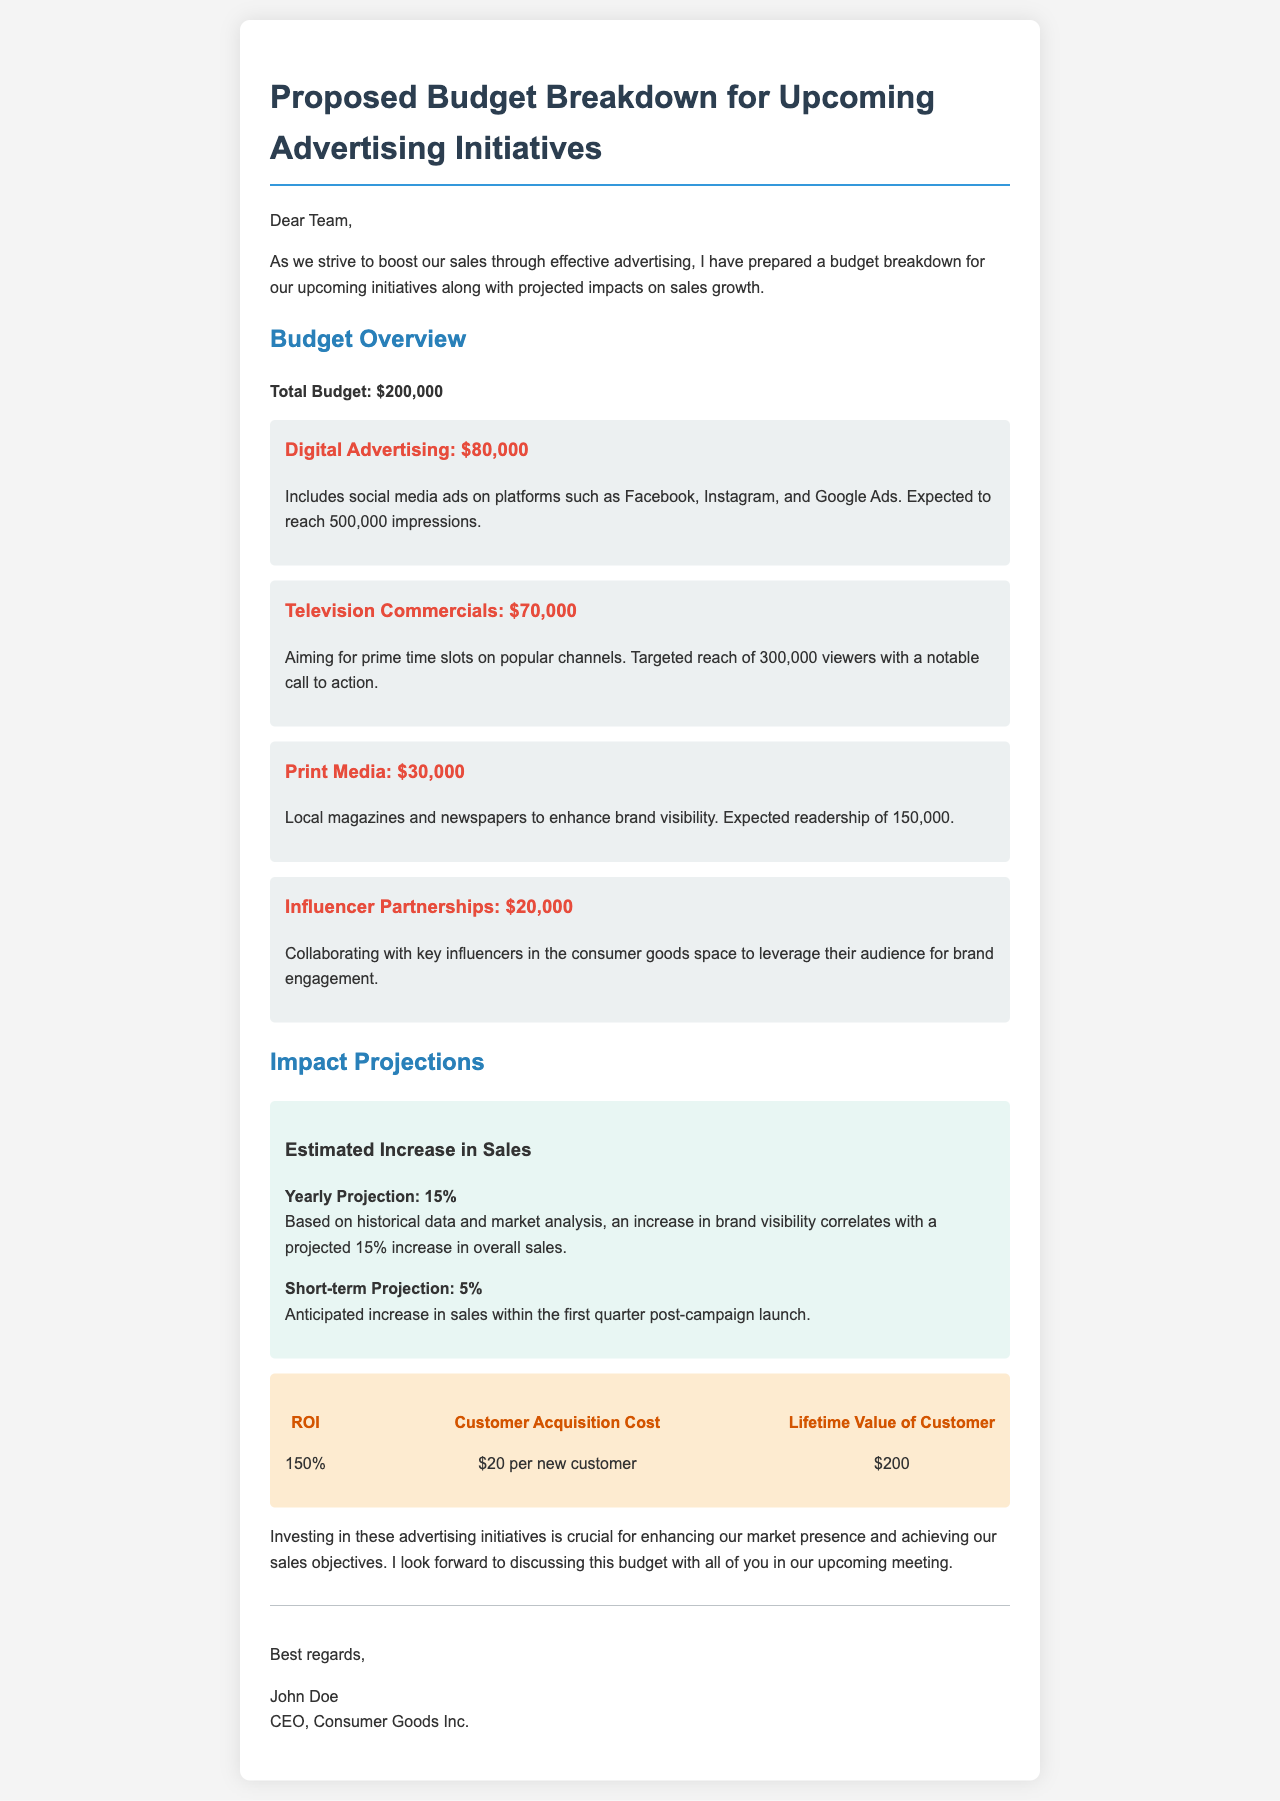What is the total budget? The total budget for the upcoming advertising initiatives is clearly stated in the document as $200,000.
Answer: $200,000 How much is allocated to digital advertising? The document specifically states that the budget allocated for digital advertising is $80,000.
Answer: $80,000 What is the projected increase in sales for the year? According to the document, the yearly projection for sales increase is 15%.
Answer: 15% What is the customer acquisition cost? The document mentions that the customer acquisition cost is $20 per new customer.
Answer: $20 What type of advertising has the lowest budget? Reviewing the budget breakdown, print media has the lowest budget allocation of $30,000.
Answer: $30,000 What is the anticipated increase in sales within the first quarter? The document indicates that the anticipated increase in sales within the first quarter post-campaign launch is 5%.
Answer: 5% Which advertising initiative has the highest budget? The highest budget allocation is for television commercials, amounting to $70,000.
Answer: $70,000 What is the expected ROI? The document provides the expected ROI as 150%.
Answer: 150% What is the target reach for television commercials? The target reach for television commercials, as stated in the document, is 300,000 viewers.
Answer: 300,000 viewers 